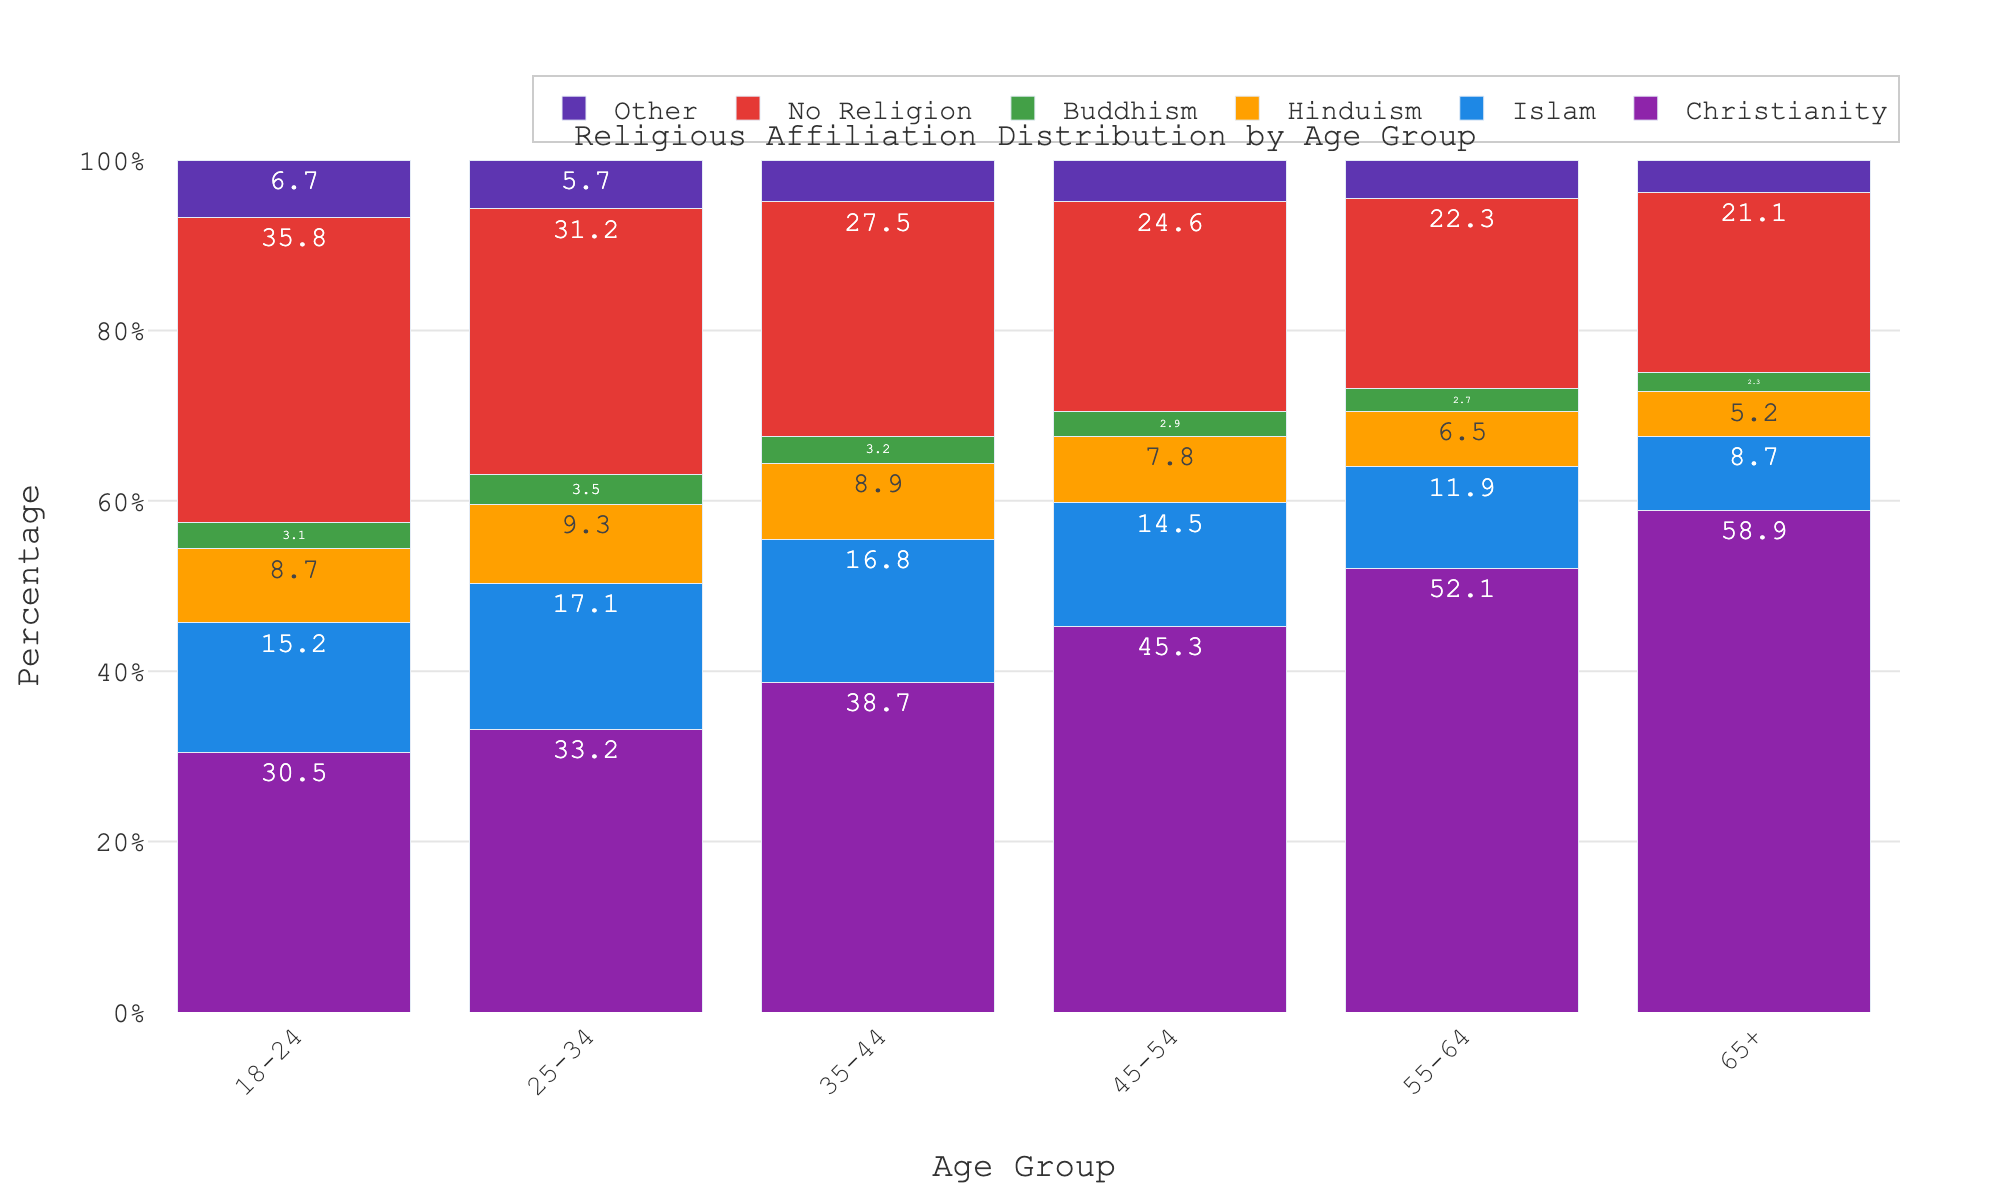What is the most common religion among the 18-24 age group? Look at the bar representing the 18-24 age group and see which religion has the highest percentage. Christianity has the highest percentage among 18-24 year-olds.
Answer: Christianity Which age group has the highest percentage of people with no religion? Compare the "No Religion" bars across all age groups and identify the tallest bar. The tallest bar is in the 18-24 age group.
Answer: 18-24 How does the percentage of people practicing Islam change from the 18-24 age group to the 65+ age group? Look at the percentage of people practicing Islam for both the 18-24 and 65+ age groups and compare the two values. The percentage decreases from 15.2% in the 18-24 age group to 8.7% in the 65+ age group.
Answer: Decreases Which religion shows the most significant increase in percentage as the age groups become older? Compare the increase in percentage of each religion from the 18-24 age group to the 65+ age group. Christianity shows the most significant increase, from 30.5% in 18-24 year-olds to 58.9% in the 65+ age group.
Answer: Christianity What is the total percentage of people following Hinduism and Buddhism in the 25-34 age group? Add the percentages of people following Hinduism and Buddhism in the 25-34 age group. The values are 9.3% for Hinduism and 3.5% for Buddhism, giving a total of 9.3% + 3.5% = 12.8%.
Answer: 12.8% Which age group has the smallest percentage of people practicing Buddhism? Compare the percentages of people practicing Buddhism across all age groups and identify the smallest value. The smallest percentage is in the 65+ age group, with 2.3%.
Answer: 65+ By how much does the percentage of people with no religion decrease from the 18-24 age group to the 55-64 age group? Subtract the percentage of people with no religion in the 55-64 age group from the percentage in the 18-24 age group. The values are 35.8% for the 18-24 age group and 22.3% for the 55-64 age group, giving a decrease of 35.8% - 22.3% = 13.5%.
Answer: 13.5% Which religion shows the least variation in percentage across all age groups? Calculate the difference between the highest and lowest percentages for each religion across all age groups and identify the smallest difference. Buddhism has the least variation, fluctuating only from 2.7% to 3.5%, a variation of 0.8 percentage points.
Answer: Buddhism What is the percentage difference between Christianity and Islam for the 45-54 age group? Subtract the percentage of Islam from the percentage of Christianity for the 45-54 age group. The values are 45.3% for Christianity and 14.5% for Islam, giving a difference of 45.3% - 14.5% = 30.8%.
Answer: 30.8% 